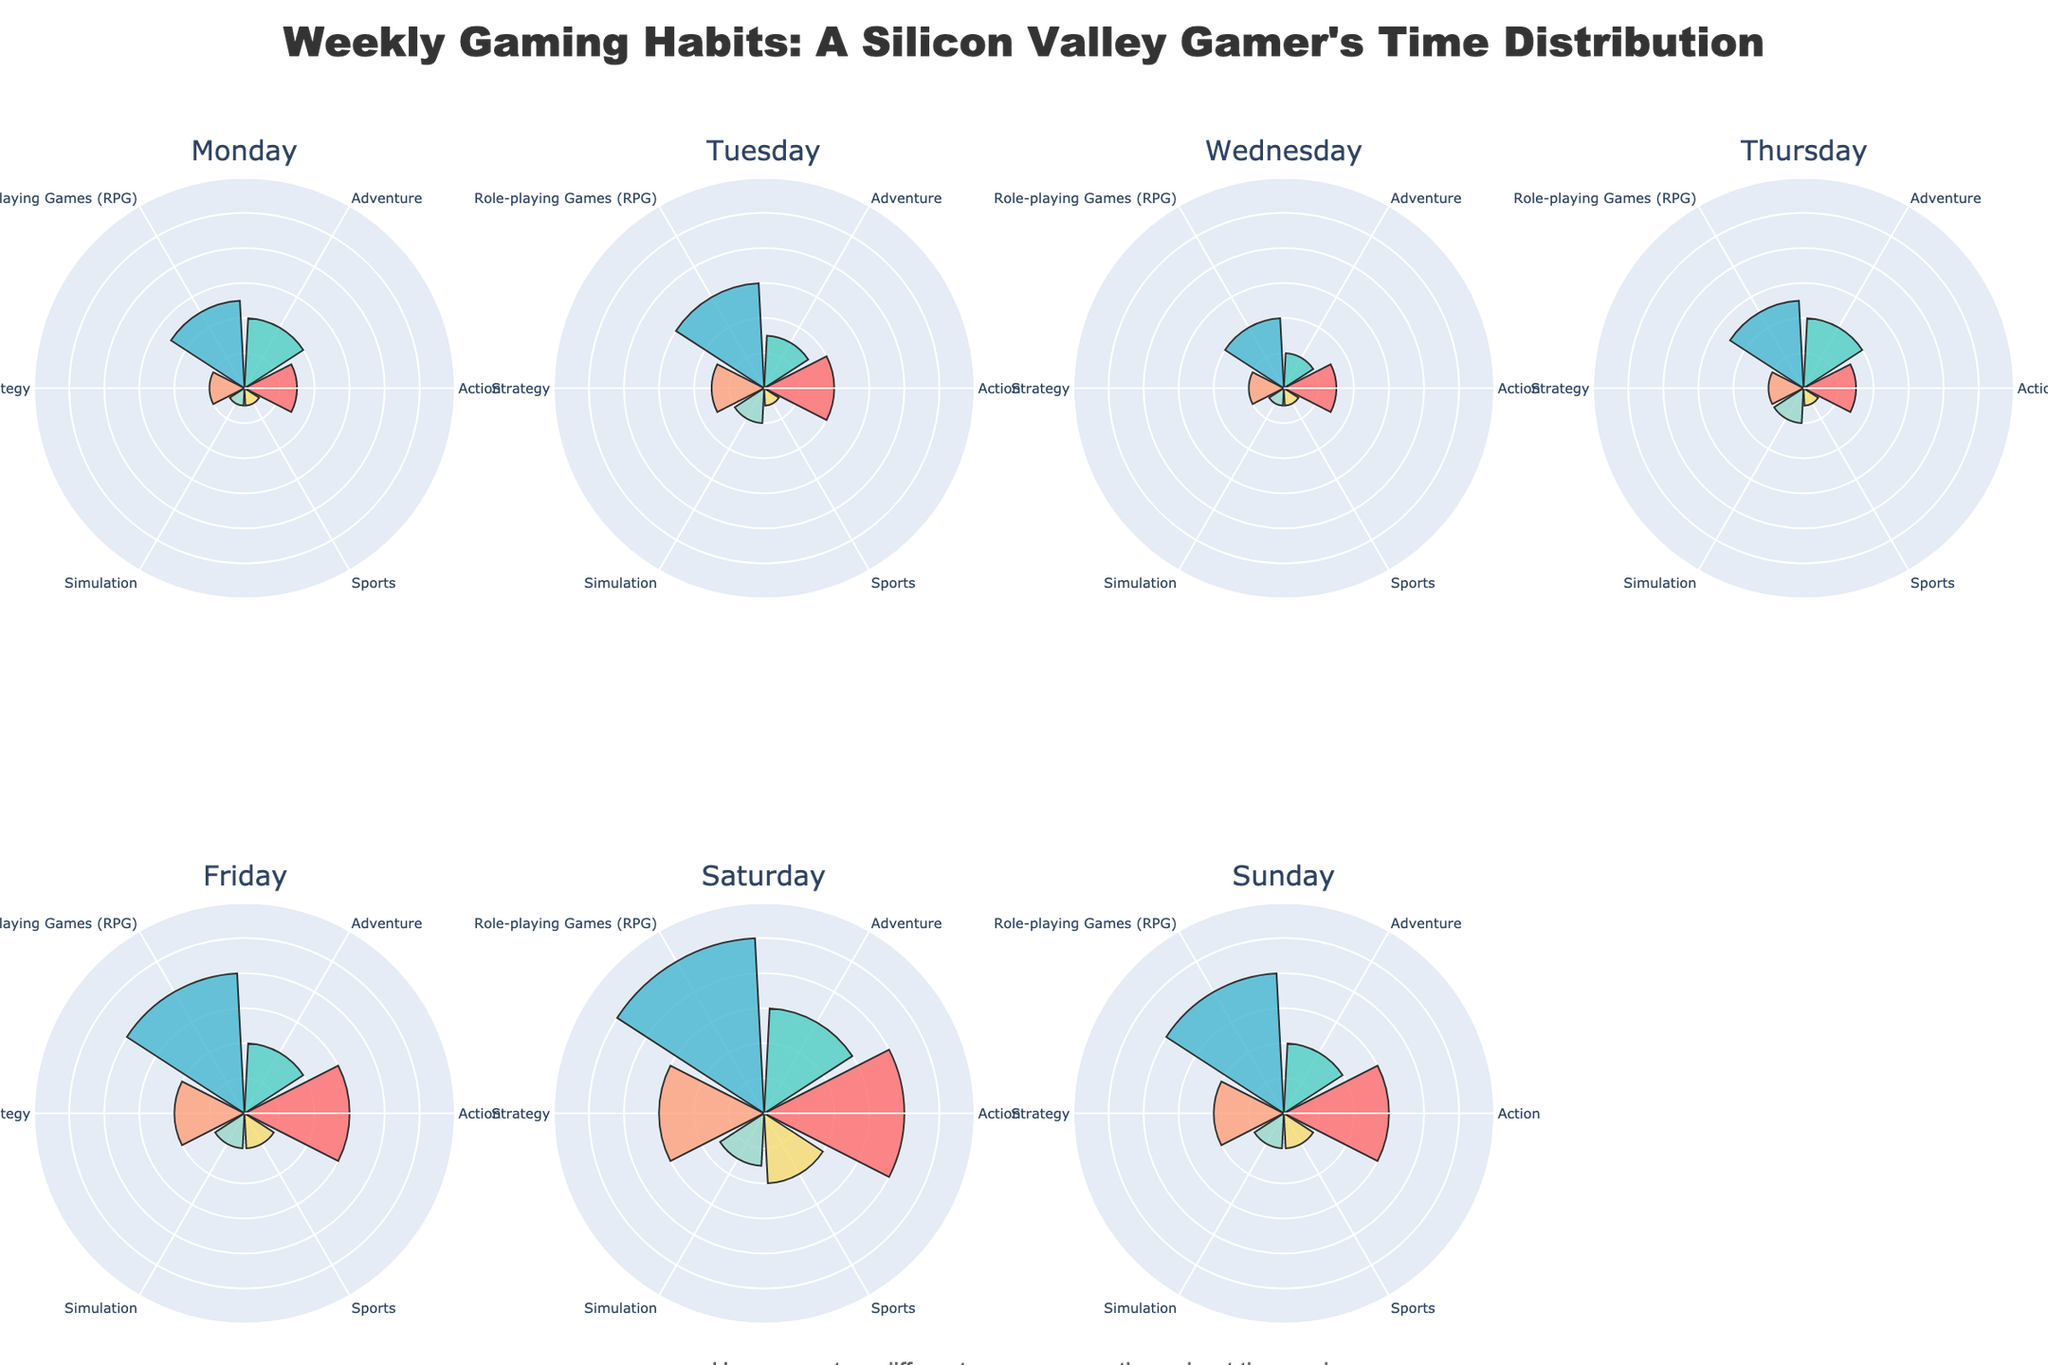Which day has the highest total hours spent on all game genres? To find the day with the highest total hours spent, sum the hours for each genre on each day and compare. Saturday totals: 4 (Action) + 3 (Adventure) + 5 (RPG) + 3 (Strategy) + 1.5 (Simulation) + 2 (Sports) = 18.5 hours, which is the highest.
Answer: Saturday What is the total number of genres? Look at the number of unique segments in any polar plot; each segment represents a different genre.
Answer: 6 On which day is the least time spent on Simulation games? Look for the shortest blue bar in the Simulation category for each day. The shortest is 0.5 hours on Monday, Wednesday, and Thursday.
Answer: Monday, Wednesday, Thursday Which genre sees the biggest increase in hours from Friday to Saturday? Compare the hours for each genre on Friday and Saturday. RPG increases from 4 to 5 hours.
Answer: RPG Which genre consistently gets at least 2 hours rating from Tuesday to Sunday? Look at each day's polar plot and check for genres with bars extending to at least 2 hours consistently from Tuesday to Sunday. RPG and Action qualify.
Answer: RPG, Action What are the total hours spent on Action games over the week? Sum the hours spent on Action games for each day: 1.5 + 2 + 1.5 + 1.5 + 3 + 4 + 3 = 17 hours.
Answer: 17 hours Which genre has the least variation in hours spent throughout the week? Observe the lengths of the bars for each genre across the week. Sports games consistently have bars close to 0.5-1 hour every day.
Answer: Sports Which day sees the highest hours spent on Strategy games? Identify the day with the longest pink bar corresponding to Strategy games. Saturday has 3 hours spent.
Answer: Saturday Is there a day where 4 or more genres have the exact same hours? Inspect each day's polar chart for 4 or more bars of the same length. None of the days match this criterion precisely.
Answer: No How does the distribution of hours change for Adventure games across the week? Note the progression of bars for Adventure games. The distribution is: Monday (2), Tuesday (1.5), Wednesday (1), Thursday (2), Friday (2), Saturday (3), Sunday (2).
Answer: Monday (2), Tuesday (1.5), Wednesday (1), Thursday (2), Friday (2), Saturday (3), Sunday (2) 